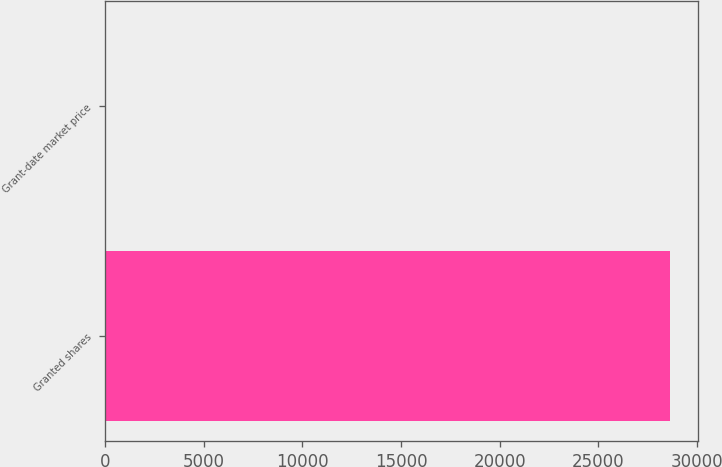Convert chart to OTSL. <chart><loc_0><loc_0><loc_500><loc_500><bar_chart><fcel>Granted shares<fcel>Grant-date market price<nl><fcel>28626<fcel>17.81<nl></chart> 